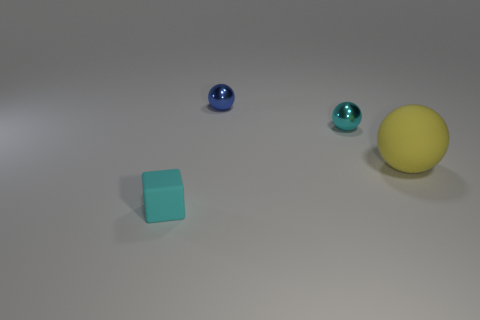How many big yellow rubber balls are on the left side of the small cyan sphere?
Offer a terse response. 0. Do the small object behind the cyan metal thing and the small cyan block have the same material?
Offer a terse response. No. How many other rubber objects have the same shape as the big yellow thing?
Your response must be concise. 0. How many small things are cyan spheres or blue metal cylinders?
Provide a short and direct response. 1. Do the rubber object that is in front of the yellow sphere and the large thing have the same color?
Ensure brevity in your answer.  No. There is a small metallic sphere that is to the left of the tiny cyan metal thing; is it the same color as the object that is in front of the big object?
Make the answer very short. No. Are there any large green things made of the same material as the small blue ball?
Ensure brevity in your answer.  No. How many yellow things are either tiny rubber blocks or shiny objects?
Your response must be concise. 0. Are there more cyan rubber cubes on the right side of the big yellow sphere than spheres?
Offer a very short reply. No. Do the cyan cube and the yellow rubber sphere have the same size?
Offer a very short reply. No. 